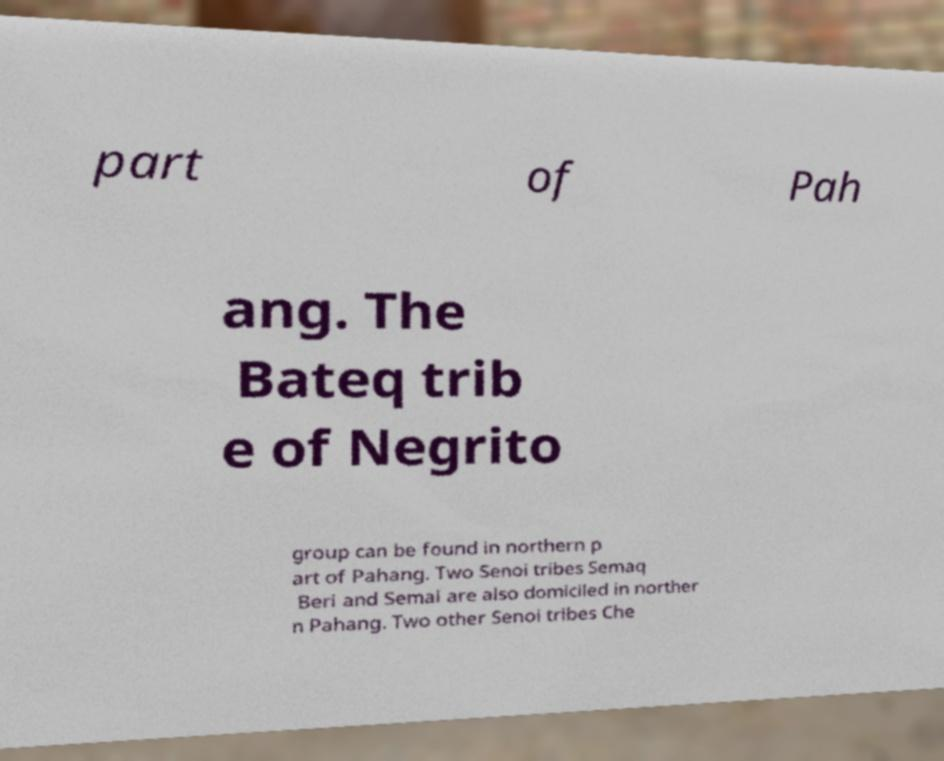Please read and relay the text visible in this image. What does it say? part of Pah ang. The Bateq trib e of Negrito group can be found in northern p art of Pahang. Two Senoi tribes Semaq Beri and Semai are also domiciled in norther n Pahang. Two other Senoi tribes Che 